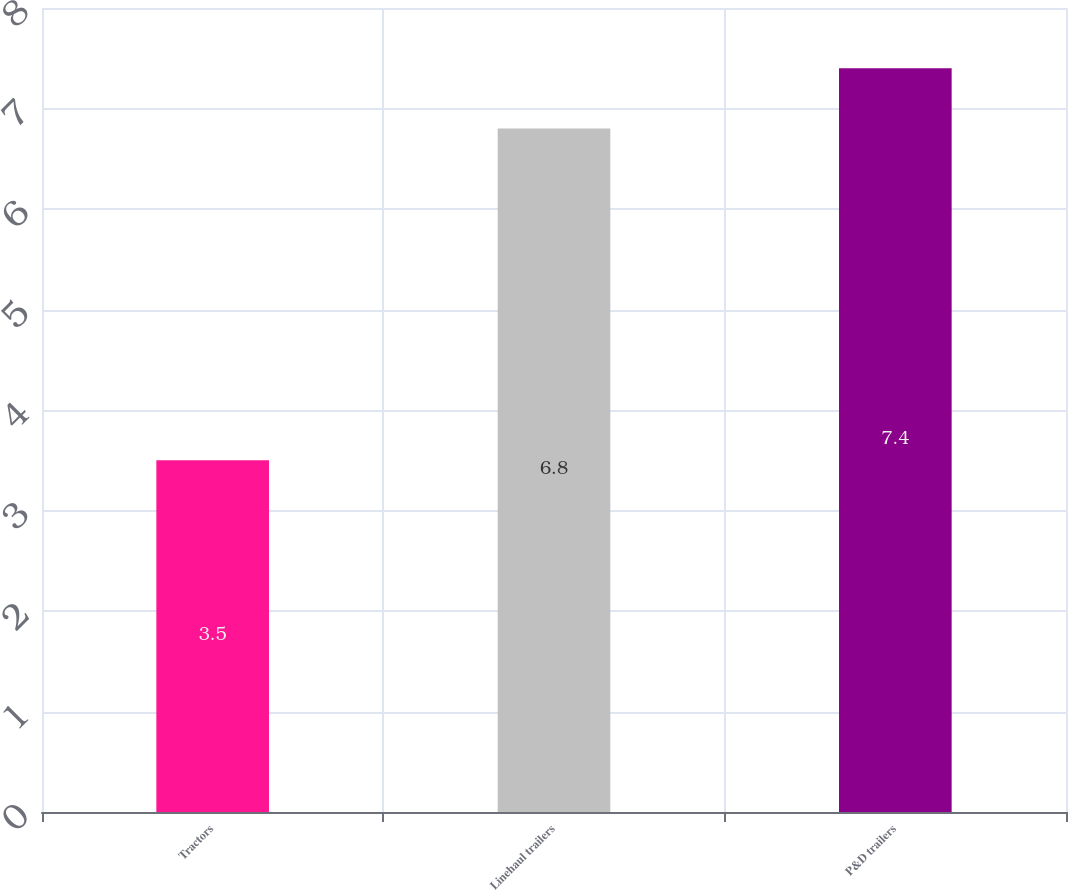Convert chart to OTSL. <chart><loc_0><loc_0><loc_500><loc_500><bar_chart><fcel>Tractors<fcel>Linehaul trailers<fcel>P&D trailers<nl><fcel>3.5<fcel>6.8<fcel>7.4<nl></chart> 